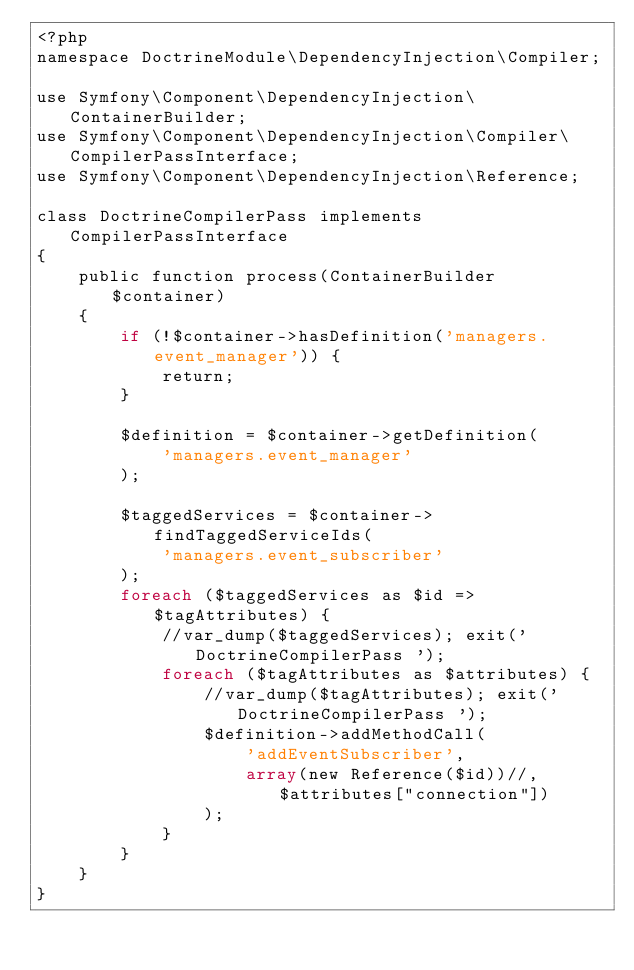<code> <loc_0><loc_0><loc_500><loc_500><_PHP_><?php
namespace DoctrineModule\DependencyInjection\Compiler;

use Symfony\Component\DependencyInjection\ContainerBuilder;
use Symfony\Component\DependencyInjection\Compiler\CompilerPassInterface;
use Symfony\Component\DependencyInjection\Reference;

class DoctrineCompilerPass implements CompilerPassInterface
{
    public function process(ContainerBuilder $container)
    {
        if (!$container->hasDefinition('managers.event_manager')) {
            return;
        }

        $definition = $container->getDefinition(
            'managers.event_manager'
        );

        $taggedServices = $container->findTaggedServiceIds(
            'managers.event_subscriber'
        );
        foreach ($taggedServices as $id => $tagAttributes) {
			//var_dump($taggedServices); exit(' DoctrineCompilerPass ');
            foreach ($tagAttributes as $attributes) {
				//var_dump($tagAttributes); exit(' DoctrineCompilerPass ');
                $definition->addMethodCall(
                    'addEventSubscriber',
                    array(new Reference($id))//, $attributes["connection"])
                );
            }
        }
    }
}
</code> 